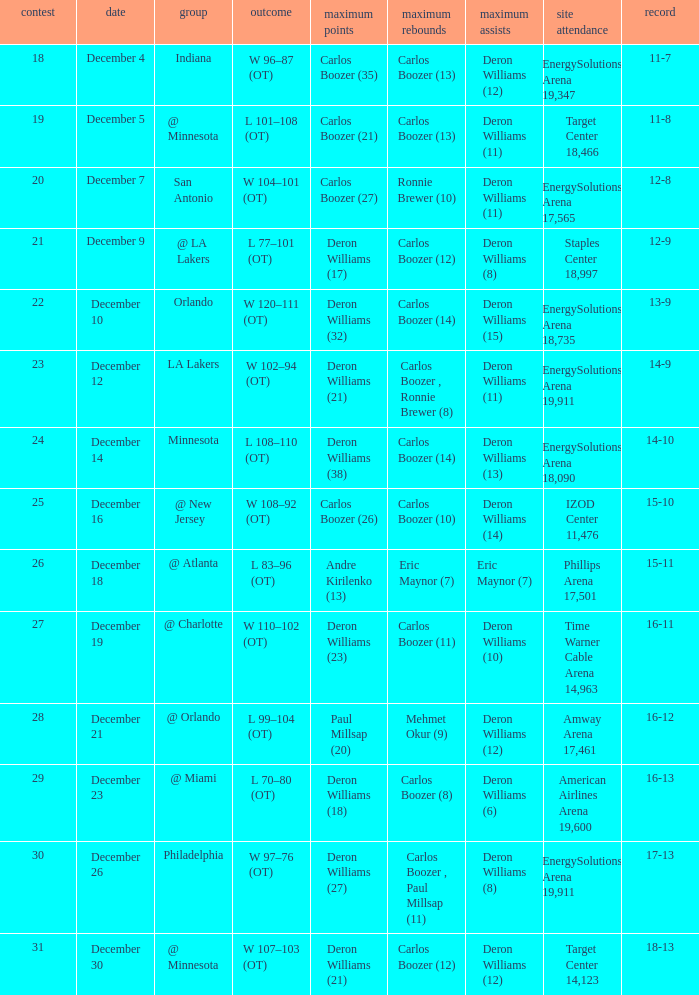When was the game in which Deron Williams (13) did the high assists played? December 14. 